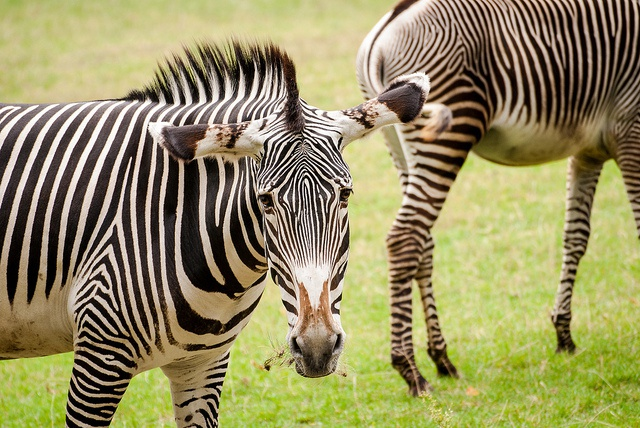Describe the objects in this image and their specific colors. I can see zebra in khaki, black, lightgray, tan, and darkgray tones and zebra in khaki, black, olive, tan, and maroon tones in this image. 